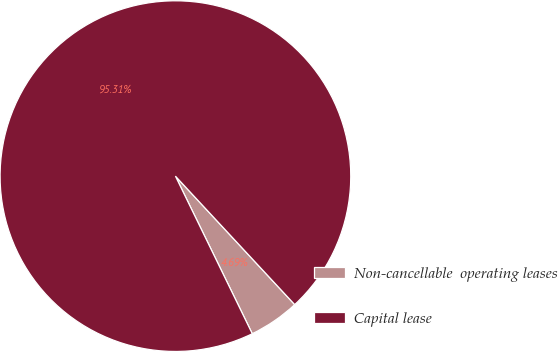Convert chart. <chart><loc_0><loc_0><loc_500><loc_500><pie_chart><fcel>Non-cancellable  operating leases<fcel>Capital lease<nl><fcel>4.69%<fcel>95.31%<nl></chart> 